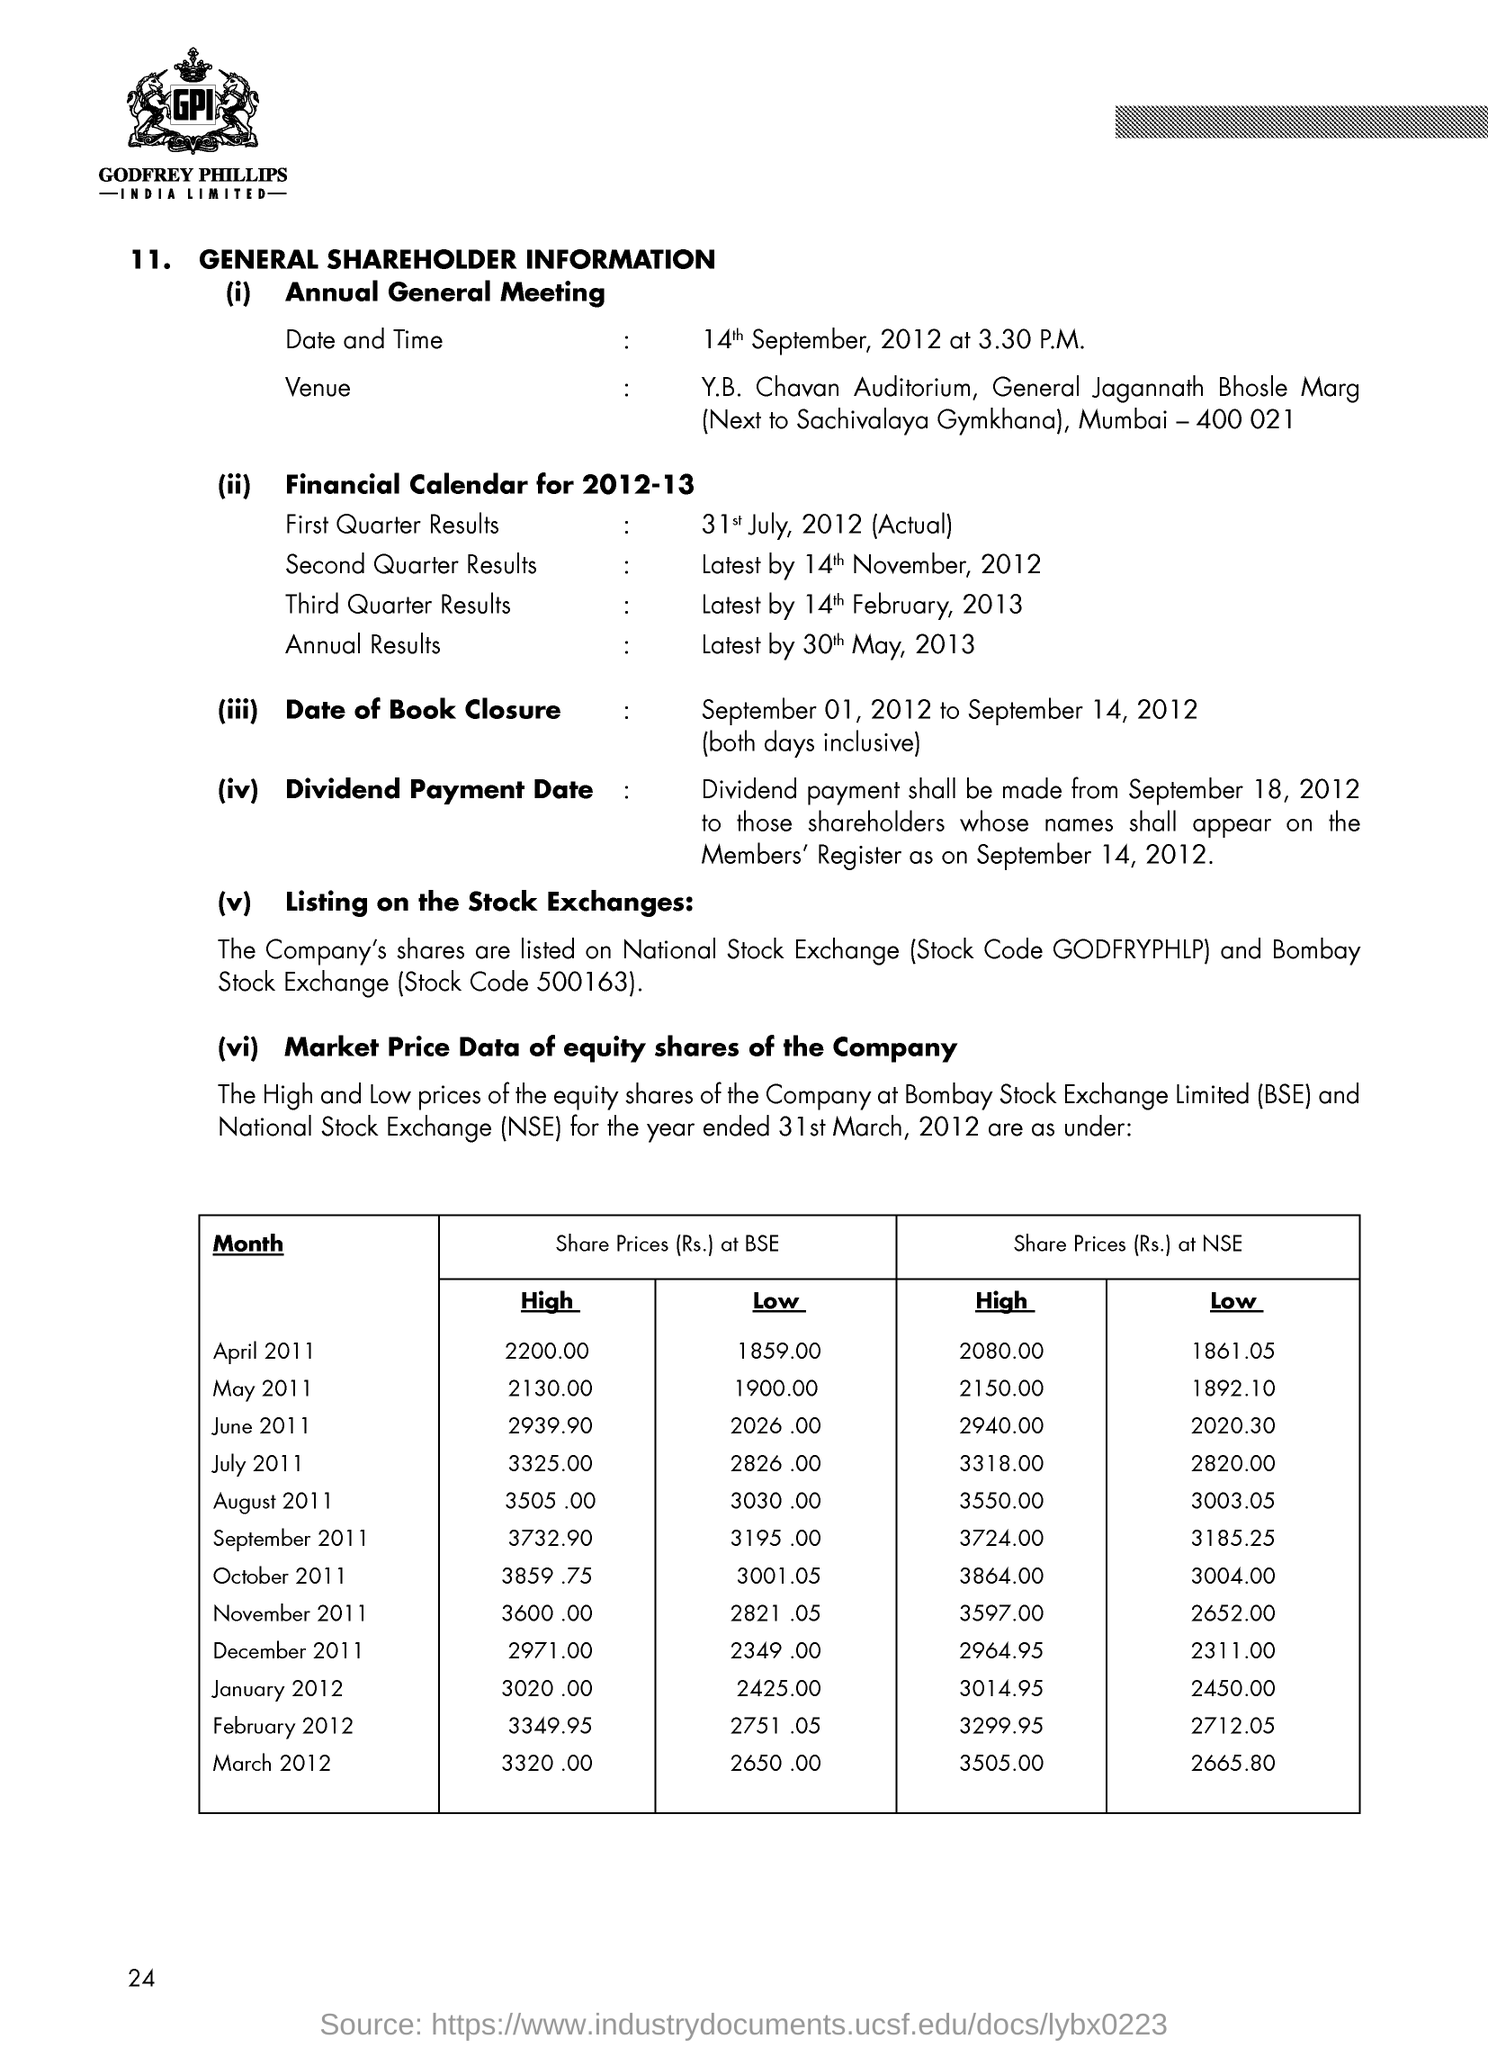What is the date and time of annual general meeting?
Offer a terse response. 14th September, 2012 at 3.30 P.M. 